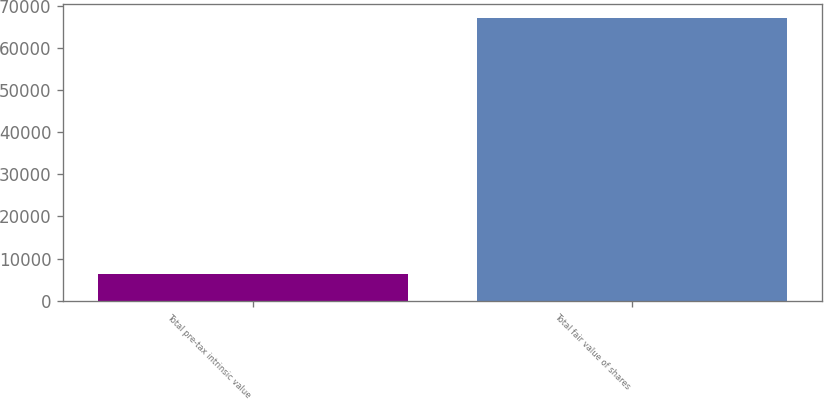<chart> <loc_0><loc_0><loc_500><loc_500><bar_chart><fcel>Total pre-tax intrinsic value<fcel>Total fair value of shares<nl><fcel>6429<fcel>67076<nl></chart> 